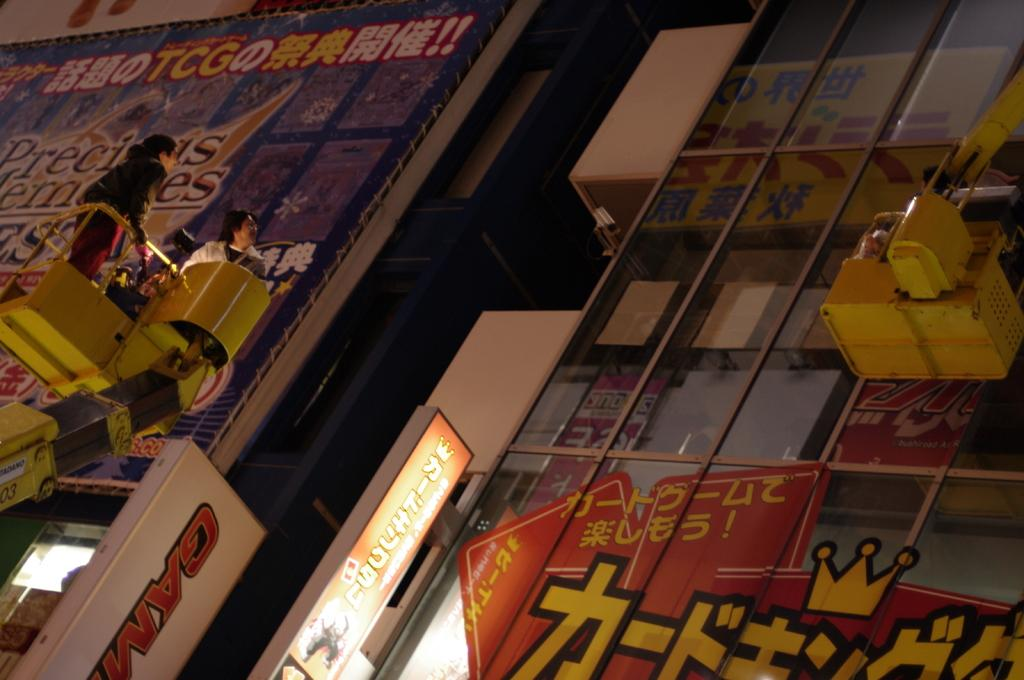Provide a one-sentence caption for the provided image. windows with chinese writing an the letters TCG in yellow in the upper left. 